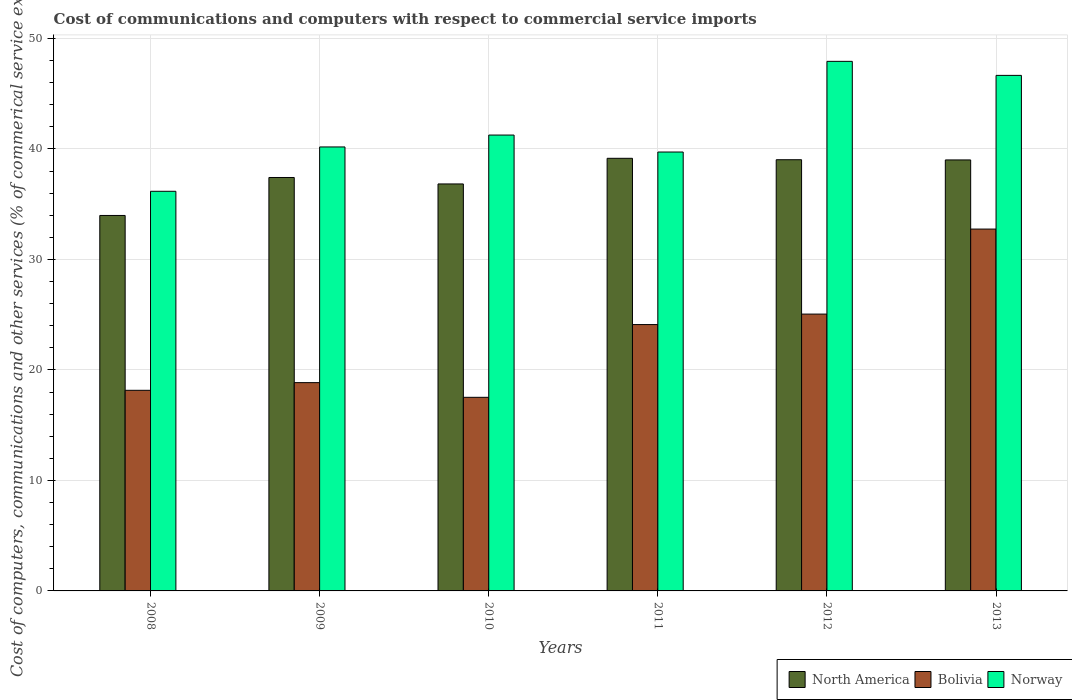How many different coloured bars are there?
Your response must be concise. 3. How many groups of bars are there?
Make the answer very short. 6. In how many cases, is the number of bars for a given year not equal to the number of legend labels?
Your answer should be compact. 0. What is the cost of communications and computers in Bolivia in 2013?
Provide a succinct answer. 32.75. Across all years, what is the maximum cost of communications and computers in Bolivia?
Offer a terse response. 32.75. Across all years, what is the minimum cost of communications and computers in North America?
Your answer should be compact. 33.98. In which year was the cost of communications and computers in North America minimum?
Your answer should be compact. 2008. What is the total cost of communications and computers in Norway in the graph?
Your answer should be compact. 251.89. What is the difference between the cost of communications and computers in Bolivia in 2011 and that in 2013?
Your answer should be very brief. -8.64. What is the difference between the cost of communications and computers in North America in 2008 and the cost of communications and computers in Norway in 2011?
Your answer should be compact. -5.74. What is the average cost of communications and computers in Bolivia per year?
Your response must be concise. 22.74. In the year 2008, what is the difference between the cost of communications and computers in Norway and cost of communications and computers in North America?
Offer a very short reply. 2.19. In how many years, is the cost of communications and computers in Bolivia greater than 16 %?
Make the answer very short. 6. What is the ratio of the cost of communications and computers in Norway in 2011 to that in 2013?
Your answer should be compact. 0.85. Is the difference between the cost of communications and computers in Norway in 2011 and 2013 greater than the difference between the cost of communications and computers in North America in 2011 and 2013?
Provide a succinct answer. No. What is the difference between the highest and the second highest cost of communications and computers in North America?
Give a very brief answer. 0.13. What is the difference between the highest and the lowest cost of communications and computers in Bolivia?
Give a very brief answer. 15.23. Is the sum of the cost of communications and computers in North America in 2011 and 2012 greater than the maximum cost of communications and computers in Bolivia across all years?
Make the answer very short. Yes. What does the 1st bar from the right in 2011 represents?
Give a very brief answer. Norway. How many bars are there?
Offer a very short reply. 18. Are all the bars in the graph horizontal?
Offer a terse response. No. Where does the legend appear in the graph?
Keep it short and to the point. Bottom right. How many legend labels are there?
Your response must be concise. 3. What is the title of the graph?
Provide a succinct answer. Cost of communications and computers with respect to commercial service imports. What is the label or title of the Y-axis?
Provide a short and direct response. Cost of computers, communications and other services (% of commerical service exports). What is the Cost of computers, communications and other services (% of commerical service exports) of North America in 2008?
Your answer should be very brief. 33.98. What is the Cost of computers, communications and other services (% of commerical service exports) in Bolivia in 2008?
Provide a succinct answer. 18.15. What is the Cost of computers, communications and other services (% of commerical service exports) of Norway in 2008?
Your answer should be compact. 36.17. What is the Cost of computers, communications and other services (% of commerical service exports) in North America in 2009?
Your answer should be very brief. 37.41. What is the Cost of computers, communications and other services (% of commerical service exports) of Bolivia in 2009?
Your answer should be compact. 18.85. What is the Cost of computers, communications and other services (% of commerical service exports) in Norway in 2009?
Offer a very short reply. 40.18. What is the Cost of computers, communications and other services (% of commerical service exports) in North America in 2010?
Your response must be concise. 36.83. What is the Cost of computers, communications and other services (% of commerical service exports) in Bolivia in 2010?
Provide a short and direct response. 17.52. What is the Cost of computers, communications and other services (% of commerical service exports) in Norway in 2010?
Your response must be concise. 41.25. What is the Cost of computers, communications and other services (% of commerical service exports) in North America in 2011?
Keep it short and to the point. 39.15. What is the Cost of computers, communications and other services (% of commerical service exports) in Bolivia in 2011?
Make the answer very short. 24.1. What is the Cost of computers, communications and other services (% of commerical service exports) in Norway in 2011?
Ensure brevity in your answer.  39.72. What is the Cost of computers, communications and other services (% of commerical service exports) of North America in 2012?
Provide a succinct answer. 39.02. What is the Cost of computers, communications and other services (% of commerical service exports) of Bolivia in 2012?
Provide a short and direct response. 25.05. What is the Cost of computers, communications and other services (% of commerical service exports) of Norway in 2012?
Ensure brevity in your answer.  47.92. What is the Cost of computers, communications and other services (% of commerical service exports) in North America in 2013?
Provide a short and direct response. 39. What is the Cost of computers, communications and other services (% of commerical service exports) of Bolivia in 2013?
Your answer should be very brief. 32.75. What is the Cost of computers, communications and other services (% of commerical service exports) in Norway in 2013?
Keep it short and to the point. 46.65. Across all years, what is the maximum Cost of computers, communications and other services (% of commerical service exports) of North America?
Your response must be concise. 39.15. Across all years, what is the maximum Cost of computers, communications and other services (% of commerical service exports) in Bolivia?
Offer a terse response. 32.75. Across all years, what is the maximum Cost of computers, communications and other services (% of commerical service exports) of Norway?
Give a very brief answer. 47.92. Across all years, what is the minimum Cost of computers, communications and other services (% of commerical service exports) in North America?
Your answer should be compact. 33.98. Across all years, what is the minimum Cost of computers, communications and other services (% of commerical service exports) in Bolivia?
Make the answer very short. 17.52. Across all years, what is the minimum Cost of computers, communications and other services (% of commerical service exports) of Norway?
Provide a short and direct response. 36.17. What is the total Cost of computers, communications and other services (% of commerical service exports) in North America in the graph?
Offer a terse response. 225.39. What is the total Cost of computers, communications and other services (% of commerical service exports) in Bolivia in the graph?
Make the answer very short. 136.43. What is the total Cost of computers, communications and other services (% of commerical service exports) in Norway in the graph?
Keep it short and to the point. 251.89. What is the difference between the Cost of computers, communications and other services (% of commerical service exports) of North America in 2008 and that in 2009?
Keep it short and to the point. -3.44. What is the difference between the Cost of computers, communications and other services (% of commerical service exports) in Bolivia in 2008 and that in 2009?
Offer a terse response. -0.69. What is the difference between the Cost of computers, communications and other services (% of commerical service exports) in Norway in 2008 and that in 2009?
Your answer should be compact. -4.01. What is the difference between the Cost of computers, communications and other services (% of commerical service exports) in North America in 2008 and that in 2010?
Provide a succinct answer. -2.85. What is the difference between the Cost of computers, communications and other services (% of commerical service exports) in Bolivia in 2008 and that in 2010?
Provide a short and direct response. 0.64. What is the difference between the Cost of computers, communications and other services (% of commerical service exports) of Norway in 2008 and that in 2010?
Provide a succinct answer. -5.09. What is the difference between the Cost of computers, communications and other services (% of commerical service exports) of North America in 2008 and that in 2011?
Your answer should be compact. -5.17. What is the difference between the Cost of computers, communications and other services (% of commerical service exports) of Bolivia in 2008 and that in 2011?
Ensure brevity in your answer.  -5.95. What is the difference between the Cost of computers, communications and other services (% of commerical service exports) of Norway in 2008 and that in 2011?
Provide a succinct answer. -3.55. What is the difference between the Cost of computers, communications and other services (% of commerical service exports) in North America in 2008 and that in 2012?
Your response must be concise. -5.04. What is the difference between the Cost of computers, communications and other services (% of commerical service exports) of Bolivia in 2008 and that in 2012?
Your answer should be very brief. -6.9. What is the difference between the Cost of computers, communications and other services (% of commerical service exports) of Norway in 2008 and that in 2012?
Your answer should be compact. -11.76. What is the difference between the Cost of computers, communications and other services (% of commerical service exports) in North America in 2008 and that in 2013?
Offer a terse response. -5.03. What is the difference between the Cost of computers, communications and other services (% of commerical service exports) of Bolivia in 2008 and that in 2013?
Give a very brief answer. -14.59. What is the difference between the Cost of computers, communications and other services (% of commerical service exports) in Norway in 2008 and that in 2013?
Offer a very short reply. -10.49. What is the difference between the Cost of computers, communications and other services (% of commerical service exports) of North America in 2009 and that in 2010?
Offer a very short reply. 0.58. What is the difference between the Cost of computers, communications and other services (% of commerical service exports) of Bolivia in 2009 and that in 2010?
Your response must be concise. 1.33. What is the difference between the Cost of computers, communications and other services (% of commerical service exports) in Norway in 2009 and that in 2010?
Make the answer very short. -1.08. What is the difference between the Cost of computers, communications and other services (% of commerical service exports) of North America in 2009 and that in 2011?
Ensure brevity in your answer.  -1.74. What is the difference between the Cost of computers, communications and other services (% of commerical service exports) in Bolivia in 2009 and that in 2011?
Provide a short and direct response. -5.25. What is the difference between the Cost of computers, communications and other services (% of commerical service exports) of Norway in 2009 and that in 2011?
Make the answer very short. 0.46. What is the difference between the Cost of computers, communications and other services (% of commerical service exports) of North America in 2009 and that in 2012?
Make the answer very short. -1.61. What is the difference between the Cost of computers, communications and other services (% of commerical service exports) in Bolivia in 2009 and that in 2012?
Offer a terse response. -6.2. What is the difference between the Cost of computers, communications and other services (% of commerical service exports) in Norway in 2009 and that in 2012?
Give a very brief answer. -7.75. What is the difference between the Cost of computers, communications and other services (% of commerical service exports) of North America in 2009 and that in 2013?
Provide a succinct answer. -1.59. What is the difference between the Cost of computers, communications and other services (% of commerical service exports) in Bolivia in 2009 and that in 2013?
Make the answer very short. -13.9. What is the difference between the Cost of computers, communications and other services (% of commerical service exports) of Norway in 2009 and that in 2013?
Provide a short and direct response. -6.48. What is the difference between the Cost of computers, communications and other services (% of commerical service exports) in North America in 2010 and that in 2011?
Your response must be concise. -2.32. What is the difference between the Cost of computers, communications and other services (% of commerical service exports) in Bolivia in 2010 and that in 2011?
Give a very brief answer. -6.58. What is the difference between the Cost of computers, communications and other services (% of commerical service exports) in Norway in 2010 and that in 2011?
Provide a succinct answer. 1.54. What is the difference between the Cost of computers, communications and other services (% of commerical service exports) of North America in 2010 and that in 2012?
Offer a terse response. -2.19. What is the difference between the Cost of computers, communications and other services (% of commerical service exports) of Bolivia in 2010 and that in 2012?
Offer a very short reply. -7.53. What is the difference between the Cost of computers, communications and other services (% of commerical service exports) of Norway in 2010 and that in 2012?
Make the answer very short. -6.67. What is the difference between the Cost of computers, communications and other services (% of commerical service exports) of North America in 2010 and that in 2013?
Ensure brevity in your answer.  -2.17. What is the difference between the Cost of computers, communications and other services (% of commerical service exports) of Bolivia in 2010 and that in 2013?
Offer a terse response. -15.23. What is the difference between the Cost of computers, communications and other services (% of commerical service exports) of Norway in 2010 and that in 2013?
Your response must be concise. -5.4. What is the difference between the Cost of computers, communications and other services (% of commerical service exports) of North America in 2011 and that in 2012?
Provide a short and direct response. 0.13. What is the difference between the Cost of computers, communications and other services (% of commerical service exports) in Bolivia in 2011 and that in 2012?
Offer a very short reply. -0.95. What is the difference between the Cost of computers, communications and other services (% of commerical service exports) of Norway in 2011 and that in 2012?
Ensure brevity in your answer.  -8.21. What is the difference between the Cost of computers, communications and other services (% of commerical service exports) in North America in 2011 and that in 2013?
Provide a short and direct response. 0.15. What is the difference between the Cost of computers, communications and other services (% of commerical service exports) in Bolivia in 2011 and that in 2013?
Your answer should be compact. -8.64. What is the difference between the Cost of computers, communications and other services (% of commerical service exports) in Norway in 2011 and that in 2013?
Make the answer very short. -6.94. What is the difference between the Cost of computers, communications and other services (% of commerical service exports) of North America in 2012 and that in 2013?
Ensure brevity in your answer.  0.02. What is the difference between the Cost of computers, communications and other services (% of commerical service exports) of Bolivia in 2012 and that in 2013?
Provide a short and direct response. -7.69. What is the difference between the Cost of computers, communications and other services (% of commerical service exports) of Norway in 2012 and that in 2013?
Your answer should be very brief. 1.27. What is the difference between the Cost of computers, communications and other services (% of commerical service exports) in North America in 2008 and the Cost of computers, communications and other services (% of commerical service exports) in Bolivia in 2009?
Ensure brevity in your answer.  15.13. What is the difference between the Cost of computers, communications and other services (% of commerical service exports) of North America in 2008 and the Cost of computers, communications and other services (% of commerical service exports) of Norway in 2009?
Your answer should be very brief. -6.2. What is the difference between the Cost of computers, communications and other services (% of commerical service exports) of Bolivia in 2008 and the Cost of computers, communications and other services (% of commerical service exports) of Norway in 2009?
Your answer should be compact. -22.02. What is the difference between the Cost of computers, communications and other services (% of commerical service exports) in North America in 2008 and the Cost of computers, communications and other services (% of commerical service exports) in Bolivia in 2010?
Your response must be concise. 16.46. What is the difference between the Cost of computers, communications and other services (% of commerical service exports) in North America in 2008 and the Cost of computers, communications and other services (% of commerical service exports) in Norway in 2010?
Keep it short and to the point. -7.28. What is the difference between the Cost of computers, communications and other services (% of commerical service exports) of Bolivia in 2008 and the Cost of computers, communications and other services (% of commerical service exports) of Norway in 2010?
Provide a short and direct response. -23.1. What is the difference between the Cost of computers, communications and other services (% of commerical service exports) in North America in 2008 and the Cost of computers, communications and other services (% of commerical service exports) in Bolivia in 2011?
Your answer should be very brief. 9.87. What is the difference between the Cost of computers, communications and other services (% of commerical service exports) in North America in 2008 and the Cost of computers, communications and other services (% of commerical service exports) in Norway in 2011?
Ensure brevity in your answer.  -5.74. What is the difference between the Cost of computers, communications and other services (% of commerical service exports) of Bolivia in 2008 and the Cost of computers, communications and other services (% of commerical service exports) of Norway in 2011?
Offer a terse response. -21.56. What is the difference between the Cost of computers, communications and other services (% of commerical service exports) in North America in 2008 and the Cost of computers, communications and other services (% of commerical service exports) in Bolivia in 2012?
Offer a very short reply. 8.92. What is the difference between the Cost of computers, communications and other services (% of commerical service exports) of North America in 2008 and the Cost of computers, communications and other services (% of commerical service exports) of Norway in 2012?
Offer a terse response. -13.95. What is the difference between the Cost of computers, communications and other services (% of commerical service exports) of Bolivia in 2008 and the Cost of computers, communications and other services (% of commerical service exports) of Norway in 2012?
Your response must be concise. -29.77. What is the difference between the Cost of computers, communications and other services (% of commerical service exports) of North America in 2008 and the Cost of computers, communications and other services (% of commerical service exports) of Bolivia in 2013?
Ensure brevity in your answer.  1.23. What is the difference between the Cost of computers, communications and other services (% of commerical service exports) of North America in 2008 and the Cost of computers, communications and other services (% of commerical service exports) of Norway in 2013?
Ensure brevity in your answer.  -12.68. What is the difference between the Cost of computers, communications and other services (% of commerical service exports) in Bolivia in 2008 and the Cost of computers, communications and other services (% of commerical service exports) in Norway in 2013?
Offer a terse response. -28.5. What is the difference between the Cost of computers, communications and other services (% of commerical service exports) of North America in 2009 and the Cost of computers, communications and other services (% of commerical service exports) of Bolivia in 2010?
Your answer should be compact. 19.89. What is the difference between the Cost of computers, communications and other services (% of commerical service exports) of North America in 2009 and the Cost of computers, communications and other services (% of commerical service exports) of Norway in 2010?
Your response must be concise. -3.84. What is the difference between the Cost of computers, communications and other services (% of commerical service exports) of Bolivia in 2009 and the Cost of computers, communications and other services (% of commerical service exports) of Norway in 2010?
Provide a succinct answer. -22.4. What is the difference between the Cost of computers, communications and other services (% of commerical service exports) of North America in 2009 and the Cost of computers, communications and other services (% of commerical service exports) of Bolivia in 2011?
Give a very brief answer. 13.31. What is the difference between the Cost of computers, communications and other services (% of commerical service exports) in North America in 2009 and the Cost of computers, communications and other services (% of commerical service exports) in Norway in 2011?
Ensure brevity in your answer.  -2.31. What is the difference between the Cost of computers, communications and other services (% of commerical service exports) in Bolivia in 2009 and the Cost of computers, communications and other services (% of commerical service exports) in Norway in 2011?
Offer a terse response. -20.87. What is the difference between the Cost of computers, communications and other services (% of commerical service exports) in North America in 2009 and the Cost of computers, communications and other services (% of commerical service exports) in Bolivia in 2012?
Keep it short and to the point. 12.36. What is the difference between the Cost of computers, communications and other services (% of commerical service exports) of North America in 2009 and the Cost of computers, communications and other services (% of commerical service exports) of Norway in 2012?
Your answer should be compact. -10.51. What is the difference between the Cost of computers, communications and other services (% of commerical service exports) in Bolivia in 2009 and the Cost of computers, communications and other services (% of commerical service exports) in Norway in 2012?
Offer a very short reply. -29.07. What is the difference between the Cost of computers, communications and other services (% of commerical service exports) of North America in 2009 and the Cost of computers, communications and other services (% of commerical service exports) of Bolivia in 2013?
Keep it short and to the point. 4.67. What is the difference between the Cost of computers, communications and other services (% of commerical service exports) in North America in 2009 and the Cost of computers, communications and other services (% of commerical service exports) in Norway in 2013?
Ensure brevity in your answer.  -9.24. What is the difference between the Cost of computers, communications and other services (% of commerical service exports) of Bolivia in 2009 and the Cost of computers, communications and other services (% of commerical service exports) of Norway in 2013?
Make the answer very short. -27.8. What is the difference between the Cost of computers, communications and other services (% of commerical service exports) of North America in 2010 and the Cost of computers, communications and other services (% of commerical service exports) of Bolivia in 2011?
Provide a succinct answer. 12.73. What is the difference between the Cost of computers, communications and other services (% of commerical service exports) of North America in 2010 and the Cost of computers, communications and other services (% of commerical service exports) of Norway in 2011?
Give a very brief answer. -2.89. What is the difference between the Cost of computers, communications and other services (% of commerical service exports) in Bolivia in 2010 and the Cost of computers, communications and other services (% of commerical service exports) in Norway in 2011?
Ensure brevity in your answer.  -22.2. What is the difference between the Cost of computers, communications and other services (% of commerical service exports) of North America in 2010 and the Cost of computers, communications and other services (% of commerical service exports) of Bolivia in 2012?
Your answer should be very brief. 11.78. What is the difference between the Cost of computers, communications and other services (% of commerical service exports) of North America in 2010 and the Cost of computers, communications and other services (% of commerical service exports) of Norway in 2012?
Your answer should be compact. -11.09. What is the difference between the Cost of computers, communications and other services (% of commerical service exports) of Bolivia in 2010 and the Cost of computers, communications and other services (% of commerical service exports) of Norway in 2012?
Your answer should be very brief. -30.4. What is the difference between the Cost of computers, communications and other services (% of commerical service exports) in North America in 2010 and the Cost of computers, communications and other services (% of commerical service exports) in Bolivia in 2013?
Give a very brief answer. 4.08. What is the difference between the Cost of computers, communications and other services (% of commerical service exports) in North America in 2010 and the Cost of computers, communications and other services (% of commerical service exports) in Norway in 2013?
Your response must be concise. -9.82. What is the difference between the Cost of computers, communications and other services (% of commerical service exports) in Bolivia in 2010 and the Cost of computers, communications and other services (% of commerical service exports) in Norway in 2013?
Make the answer very short. -29.13. What is the difference between the Cost of computers, communications and other services (% of commerical service exports) of North America in 2011 and the Cost of computers, communications and other services (% of commerical service exports) of Bolivia in 2012?
Your answer should be very brief. 14.1. What is the difference between the Cost of computers, communications and other services (% of commerical service exports) of North America in 2011 and the Cost of computers, communications and other services (% of commerical service exports) of Norway in 2012?
Your answer should be very brief. -8.77. What is the difference between the Cost of computers, communications and other services (% of commerical service exports) of Bolivia in 2011 and the Cost of computers, communications and other services (% of commerical service exports) of Norway in 2012?
Your answer should be very brief. -23.82. What is the difference between the Cost of computers, communications and other services (% of commerical service exports) in North America in 2011 and the Cost of computers, communications and other services (% of commerical service exports) in Bolivia in 2013?
Your answer should be very brief. 6.4. What is the difference between the Cost of computers, communications and other services (% of commerical service exports) of North America in 2011 and the Cost of computers, communications and other services (% of commerical service exports) of Norway in 2013?
Provide a succinct answer. -7.5. What is the difference between the Cost of computers, communications and other services (% of commerical service exports) in Bolivia in 2011 and the Cost of computers, communications and other services (% of commerical service exports) in Norway in 2013?
Offer a very short reply. -22.55. What is the difference between the Cost of computers, communications and other services (% of commerical service exports) in North America in 2012 and the Cost of computers, communications and other services (% of commerical service exports) in Bolivia in 2013?
Ensure brevity in your answer.  6.27. What is the difference between the Cost of computers, communications and other services (% of commerical service exports) in North America in 2012 and the Cost of computers, communications and other services (% of commerical service exports) in Norway in 2013?
Your response must be concise. -7.63. What is the difference between the Cost of computers, communications and other services (% of commerical service exports) of Bolivia in 2012 and the Cost of computers, communications and other services (% of commerical service exports) of Norway in 2013?
Keep it short and to the point. -21.6. What is the average Cost of computers, communications and other services (% of commerical service exports) in North America per year?
Offer a very short reply. 37.57. What is the average Cost of computers, communications and other services (% of commerical service exports) of Bolivia per year?
Your response must be concise. 22.74. What is the average Cost of computers, communications and other services (% of commerical service exports) in Norway per year?
Provide a short and direct response. 41.98. In the year 2008, what is the difference between the Cost of computers, communications and other services (% of commerical service exports) of North America and Cost of computers, communications and other services (% of commerical service exports) of Bolivia?
Offer a terse response. 15.82. In the year 2008, what is the difference between the Cost of computers, communications and other services (% of commerical service exports) of North America and Cost of computers, communications and other services (% of commerical service exports) of Norway?
Give a very brief answer. -2.19. In the year 2008, what is the difference between the Cost of computers, communications and other services (% of commerical service exports) in Bolivia and Cost of computers, communications and other services (% of commerical service exports) in Norway?
Provide a succinct answer. -18.01. In the year 2009, what is the difference between the Cost of computers, communications and other services (% of commerical service exports) in North America and Cost of computers, communications and other services (% of commerical service exports) in Bolivia?
Keep it short and to the point. 18.56. In the year 2009, what is the difference between the Cost of computers, communications and other services (% of commerical service exports) of North America and Cost of computers, communications and other services (% of commerical service exports) of Norway?
Your answer should be very brief. -2.76. In the year 2009, what is the difference between the Cost of computers, communications and other services (% of commerical service exports) in Bolivia and Cost of computers, communications and other services (% of commerical service exports) in Norway?
Your answer should be compact. -21.33. In the year 2010, what is the difference between the Cost of computers, communications and other services (% of commerical service exports) of North America and Cost of computers, communications and other services (% of commerical service exports) of Bolivia?
Provide a short and direct response. 19.31. In the year 2010, what is the difference between the Cost of computers, communications and other services (% of commerical service exports) of North America and Cost of computers, communications and other services (% of commerical service exports) of Norway?
Provide a short and direct response. -4.42. In the year 2010, what is the difference between the Cost of computers, communications and other services (% of commerical service exports) of Bolivia and Cost of computers, communications and other services (% of commerical service exports) of Norway?
Your answer should be very brief. -23.73. In the year 2011, what is the difference between the Cost of computers, communications and other services (% of commerical service exports) of North America and Cost of computers, communications and other services (% of commerical service exports) of Bolivia?
Your answer should be very brief. 15.05. In the year 2011, what is the difference between the Cost of computers, communications and other services (% of commerical service exports) of North America and Cost of computers, communications and other services (% of commerical service exports) of Norway?
Give a very brief answer. -0.57. In the year 2011, what is the difference between the Cost of computers, communications and other services (% of commerical service exports) in Bolivia and Cost of computers, communications and other services (% of commerical service exports) in Norway?
Your answer should be very brief. -15.61. In the year 2012, what is the difference between the Cost of computers, communications and other services (% of commerical service exports) in North America and Cost of computers, communications and other services (% of commerical service exports) in Bolivia?
Give a very brief answer. 13.97. In the year 2012, what is the difference between the Cost of computers, communications and other services (% of commerical service exports) in North America and Cost of computers, communications and other services (% of commerical service exports) in Norway?
Your response must be concise. -8.9. In the year 2012, what is the difference between the Cost of computers, communications and other services (% of commerical service exports) of Bolivia and Cost of computers, communications and other services (% of commerical service exports) of Norway?
Keep it short and to the point. -22.87. In the year 2013, what is the difference between the Cost of computers, communications and other services (% of commerical service exports) in North America and Cost of computers, communications and other services (% of commerical service exports) in Bolivia?
Make the answer very short. 6.26. In the year 2013, what is the difference between the Cost of computers, communications and other services (% of commerical service exports) of North America and Cost of computers, communications and other services (% of commerical service exports) of Norway?
Keep it short and to the point. -7.65. In the year 2013, what is the difference between the Cost of computers, communications and other services (% of commerical service exports) in Bolivia and Cost of computers, communications and other services (% of commerical service exports) in Norway?
Your response must be concise. -13.91. What is the ratio of the Cost of computers, communications and other services (% of commerical service exports) of North America in 2008 to that in 2009?
Offer a very short reply. 0.91. What is the ratio of the Cost of computers, communications and other services (% of commerical service exports) in Bolivia in 2008 to that in 2009?
Make the answer very short. 0.96. What is the ratio of the Cost of computers, communications and other services (% of commerical service exports) of Norway in 2008 to that in 2009?
Provide a short and direct response. 0.9. What is the ratio of the Cost of computers, communications and other services (% of commerical service exports) of North America in 2008 to that in 2010?
Offer a terse response. 0.92. What is the ratio of the Cost of computers, communications and other services (% of commerical service exports) in Bolivia in 2008 to that in 2010?
Your answer should be very brief. 1.04. What is the ratio of the Cost of computers, communications and other services (% of commerical service exports) in Norway in 2008 to that in 2010?
Make the answer very short. 0.88. What is the ratio of the Cost of computers, communications and other services (% of commerical service exports) of North America in 2008 to that in 2011?
Ensure brevity in your answer.  0.87. What is the ratio of the Cost of computers, communications and other services (% of commerical service exports) in Bolivia in 2008 to that in 2011?
Provide a succinct answer. 0.75. What is the ratio of the Cost of computers, communications and other services (% of commerical service exports) of Norway in 2008 to that in 2011?
Keep it short and to the point. 0.91. What is the ratio of the Cost of computers, communications and other services (% of commerical service exports) in North America in 2008 to that in 2012?
Offer a terse response. 0.87. What is the ratio of the Cost of computers, communications and other services (% of commerical service exports) in Bolivia in 2008 to that in 2012?
Make the answer very short. 0.72. What is the ratio of the Cost of computers, communications and other services (% of commerical service exports) of Norway in 2008 to that in 2012?
Your answer should be compact. 0.75. What is the ratio of the Cost of computers, communications and other services (% of commerical service exports) in North America in 2008 to that in 2013?
Make the answer very short. 0.87. What is the ratio of the Cost of computers, communications and other services (% of commerical service exports) in Bolivia in 2008 to that in 2013?
Keep it short and to the point. 0.55. What is the ratio of the Cost of computers, communications and other services (% of commerical service exports) in Norway in 2008 to that in 2013?
Your response must be concise. 0.78. What is the ratio of the Cost of computers, communications and other services (% of commerical service exports) of North America in 2009 to that in 2010?
Give a very brief answer. 1.02. What is the ratio of the Cost of computers, communications and other services (% of commerical service exports) in Bolivia in 2009 to that in 2010?
Your answer should be very brief. 1.08. What is the ratio of the Cost of computers, communications and other services (% of commerical service exports) of Norway in 2009 to that in 2010?
Your response must be concise. 0.97. What is the ratio of the Cost of computers, communications and other services (% of commerical service exports) in North America in 2009 to that in 2011?
Your answer should be compact. 0.96. What is the ratio of the Cost of computers, communications and other services (% of commerical service exports) of Bolivia in 2009 to that in 2011?
Make the answer very short. 0.78. What is the ratio of the Cost of computers, communications and other services (% of commerical service exports) of Norway in 2009 to that in 2011?
Offer a terse response. 1.01. What is the ratio of the Cost of computers, communications and other services (% of commerical service exports) of North America in 2009 to that in 2012?
Provide a succinct answer. 0.96. What is the ratio of the Cost of computers, communications and other services (% of commerical service exports) of Bolivia in 2009 to that in 2012?
Ensure brevity in your answer.  0.75. What is the ratio of the Cost of computers, communications and other services (% of commerical service exports) in Norway in 2009 to that in 2012?
Keep it short and to the point. 0.84. What is the ratio of the Cost of computers, communications and other services (% of commerical service exports) of North America in 2009 to that in 2013?
Provide a short and direct response. 0.96. What is the ratio of the Cost of computers, communications and other services (% of commerical service exports) in Bolivia in 2009 to that in 2013?
Offer a terse response. 0.58. What is the ratio of the Cost of computers, communications and other services (% of commerical service exports) in Norway in 2009 to that in 2013?
Ensure brevity in your answer.  0.86. What is the ratio of the Cost of computers, communications and other services (% of commerical service exports) of North America in 2010 to that in 2011?
Give a very brief answer. 0.94. What is the ratio of the Cost of computers, communications and other services (% of commerical service exports) of Bolivia in 2010 to that in 2011?
Give a very brief answer. 0.73. What is the ratio of the Cost of computers, communications and other services (% of commerical service exports) in Norway in 2010 to that in 2011?
Provide a short and direct response. 1.04. What is the ratio of the Cost of computers, communications and other services (% of commerical service exports) of North America in 2010 to that in 2012?
Give a very brief answer. 0.94. What is the ratio of the Cost of computers, communications and other services (% of commerical service exports) of Bolivia in 2010 to that in 2012?
Ensure brevity in your answer.  0.7. What is the ratio of the Cost of computers, communications and other services (% of commerical service exports) in Norway in 2010 to that in 2012?
Offer a terse response. 0.86. What is the ratio of the Cost of computers, communications and other services (% of commerical service exports) of North America in 2010 to that in 2013?
Your answer should be compact. 0.94. What is the ratio of the Cost of computers, communications and other services (% of commerical service exports) of Bolivia in 2010 to that in 2013?
Offer a very short reply. 0.54. What is the ratio of the Cost of computers, communications and other services (% of commerical service exports) of Norway in 2010 to that in 2013?
Provide a short and direct response. 0.88. What is the ratio of the Cost of computers, communications and other services (% of commerical service exports) of North America in 2011 to that in 2012?
Keep it short and to the point. 1. What is the ratio of the Cost of computers, communications and other services (% of commerical service exports) of Bolivia in 2011 to that in 2012?
Provide a succinct answer. 0.96. What is the ratio of the Cost of computers, communications and other services (% of commerical service exports) of Norway in 2011 to that in 2012?
Your answer should be compact. 0.83. What is the ratio of the Cost of computers, communications and other services (% of commerical service exports) in North America in 2011 to that in 2013?
Ensure brevity in your answer.  1. What is the ratio of the Cost of computers, communications and other services (% of commerical service exports) of Bolivia in 2011 to that in 2013?
Your answer should be compact. 0.74. What is the ratio of the Cost of computers, communications and other services (% of commerical service exports) of Norway in 2011 to that in 2013?
Make the answer very short. 0.85. What is the ratio of the Cost of computers, communications and other services (% of commerical service exports) in Bolivia in 2012 to that in 2013?
Your answer should be very brief. 0.77. What is the ratio of the Cost of computers, communications and other services (% of commerical service exports) in Norway in 2012 to that in 2013?
Make the answer very short. 1.03. What is the difference between the highest and the second highest Cost of computers, communications and other services (% of commerical service exports) of North America?
Offer a very short reply. 0.13. What is the difference between the highest and the second highest Cost of computers, communications and other services (% of commerical service exports) in Bolivia?
Ensure brevity in your answer.  7.69. What is the difference between the highest and the second highest Cost of computers, communications and other services (% of commerical service exports) of Norway?
Give a very brief answer. 1.27. What is the difference between the highest and the lowest Cost of computers, communications and other services (% of commerical service exports) of North America?
Your response must be concise. 5.17. What is the difference between the highest and the lowest Cost of computers, communications and other services (% of commerical service exports) in Bolivia?
Your answer should be very brief. 15.23. What is the difference between the highest and the lowest Cost of computers, communications and other services (% of commerical service exports) of Norway?
Give a very brief answer. 11.76. 